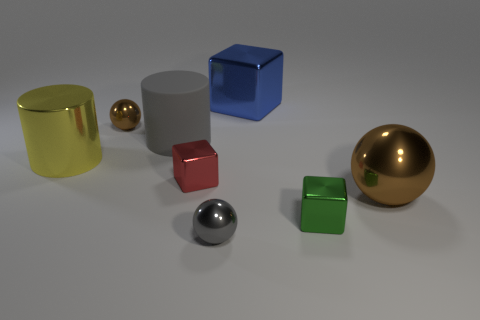Is the color of the big metal sphere the same as the rubber cylinder?
Make the answer very short. No. How many tiny metal things are the same color as the big metallic ball?
Your response must be concise. 1. Do the small red cube to the left of the big sphere and the large ball on the right side of the blue metallic object have the same material?
Your answer should be very brief. Yes. There is a blue thing that is the same size as the yellow metal thing; what shape is it?
Offer a very short reply. Cube. Are there fewer small red cubes than balls?
Offer a very short reply. Yes. Is there a cylinder on the right side of the brown metal thing that is to the right of the tiny green metallic object?
Give a very brief answer. No. There is a tiny metallic object in front of the tiny cube in front of the big brown ball; is there a brown thing that is in front of it?
Your answer should be very brief. No. Is the shape of the large shiny thing left of the tiny red shiny thing the same as the brown shiny object left of the blue thing?
Offer a terse response. No. There is a big cylinder that is made of the same material as the tiny brown object; what color is it?
Give a very brief answer. Yellow. Are there fewer tiny blocks behind the yellow metallic cylinder than large red rubber cylinders?
Give a very brief answer. No. 